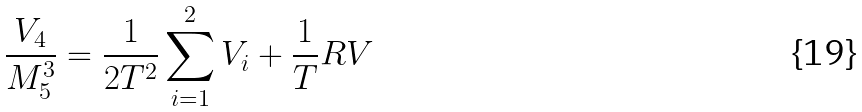Convert formula to latex. <formula><loc_0><loc_0><loc_500><loc_500>\frac { V _ { 4 } } { M _ { 5 } ^ { 3 } } = \frac { 1 } { 2 T ^ { 2 } } \sum _ { i = 1 } ^ { 2 } V _ { i } + \frac { 1 } { T } R V</formula> 